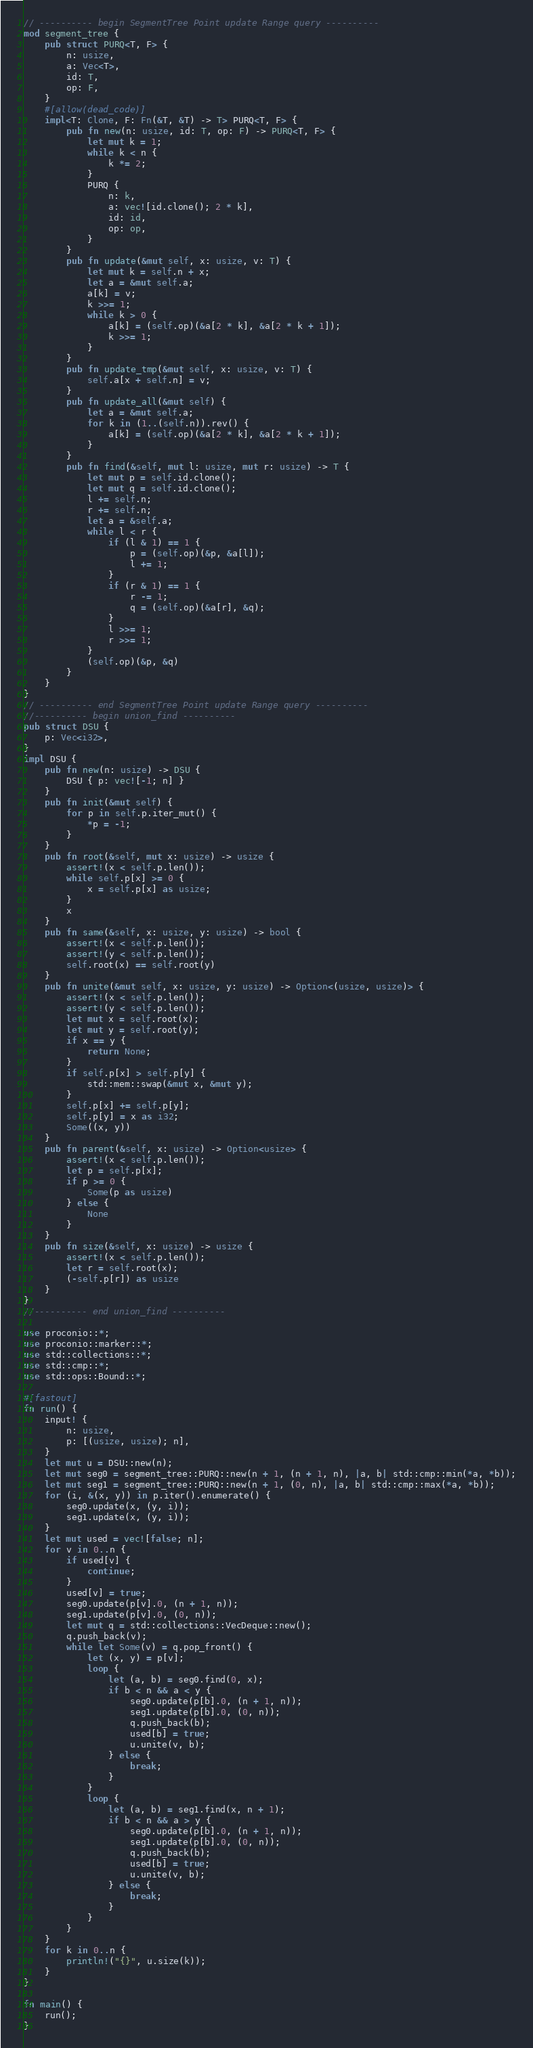Convert code to text. <code><loc_0><loc_0><loc_500><loc_500><_Rust_>// ---------- begin SegmentTree Point update Range query ----------
mod segment_tree {
    pub struct PURQ<T, F> {
        n: usize,
        a: Vec<T>,
        id: T,
        op: F,
    }
    #[allow(dead_code)]
    impl<T: Clone, F: Fn(&T, &T) -> T> PURQ<T, F> {
        pub fn new(n: usize, id: T, op: F) -> PURQ<T, F> {
            let mut k = 1;
            while k < n {
                k *= 2;
            }
            PURQ {
                n: k,
                a: vec![id.clone(); 2 * k],
                id: id,
                op: op,
            }
        }
        pub fn update(&mut self, x: usize, v: T) {
            let mut k = self.n + x;
            let a = &mut self.a;
            a[k] = v;
            k >>= 1;
            while k > 0 {
                a[k] = (self.op)(&a[2 * k], &a[2 * k + 1]);
                k >>= 1;
            }
        }
        pub fn update_tmp(&mut self, x: usize, v: T) {
            self.a[x + self.n] = v;
        }
        pub fn update_all(&mut self) {
            let a = &mut self.a;
            for k in (1..(self.n)).rev() {
                a[k] = (self.op)(&a[2 * k], &a[2 * k + 1]);
            }
        }
        pub fn find(&self, mut l: usize, mut r: usize) -> T {
            let mut p = self.id.clone();
            let mut q = self.id.clone();
            l += self.n;
            r += self.n;
            let a = &self.a;
            while l < r {
                if (l & 1) == 1 {
                    p = (self.op)(&p, &a[l]);
                    l += 1;
                }
                if (r & 1) == 1 {
                    r -= 1;
                    q = (self.op)(&a[r], &q);
                }
                l >>= 1;
                r >>= 1;
            }
            (self.op)(&p, &q)
        }
    }
}
// ---------- end SegmentTree Point update Range query ----------
//---------- begin union_find ----------
pub struct DSU {
    p: Vec<i32>,
}
impl DSU {
    pub fn new(n: usize) -> DSU {
        DSU { p: vec![-1; n] }
    }
    pub fn init(&mut self) {
        for p in self.p.iter_mut() {
            *p = -1;
        }
    }
    pub fn root(&self, mut x: usize) -> usize {
        assert!(x < self.p.len());
        while self.p[x] >= 0 {
            x = self.p[x] as usize;
        }
        x
    }
    pub fn same(&self, x: usize, y: usize) -> bool {
        assert!(x < self.p.len());
        assert!(y < self.p.len());
        self.root(x) == self.root(y)
    }
    pub fn unite(&mut self, x: usize, y: usize) -> Option<(usize, usize)> {
        assert!(x < self.p.len());
        assert!(y < self.p.len());
        let mut x = self.root(x);
        let mut y = self.root(y);
        if x == y {
            return None;
        }
        if self.p[x] > self.p[y] {
            std::mem::swap(&mut x, &mut y);
        }
        self.p[x] += self.p[y];
        self.p[y] = x as i32;
        Some((x, y))
    }
    pub fn parent(&self, x: usize) -> Option<usize> {
        assert!(x < self.p.len());
        let p = self.p[x];
        if p >= 0 {
            Some(p as usize)
        } else {
            None
        }
    }
    pub fn size(&self, x: usize) -> usize {
        assert!(x < self.p.len());
        let r = self.root(x);
        (-self.p[r]) as usize
    }
}
//---------- end union_find ----------

use proconio::*;
use proconio::marker::*;
use std::collections::*;
use std::cmp::*;
use std::ops::Bound::*;

#[fastout]
fn run() {
    input! {
        n: usize,
        p: [(usize, usize); n],
    }
    let mut u = DSU::new(n);
    let mut seg0 = segment_tree::PURQ::new(n + 1, (n + 1, n), |a, b| std::cmp::min(*a, *b));
    let mut seg1 = segment_tree::PURQ::new(n + 1, (0, n), |a, b| std::cmp::max(*a, *b));
    for (i, &(x, y)) in p.iter().enumerate() {
        seg0.update(x, (y, i));
        seg1.update(x, (y, i));
    }
    let mut used = vec![false; n];
    for v in 0..n {
        if used[v] {
            continue;
        }
        used[v] = true;
        seg0.update(p[v].0, (n + 1, n));
        seg1.update(p[v].0, (0, n));
        let mut q = std::collections::VecDeque::new();
        q.push_back(v);
        while let Some(v) = q.pop_front() {
            let (x, y) = p[v];
            loop {
                let (a, b) = seg0.find(0, x);
                if b < n && a < y {
                    seg0.update(p[b].0, (n + 1, n));
                    seg1.update(p[b].0, (0, n));
                    q.push_back(b);
                    used[b] = true;
                    u.unite(v, b);
                } else {
                    break;
                }
            }
            loop {
                let (a, b) = seg1.find(x, n + 1);
                if b < n && a > y {
                    seg0.update(p[b].0, (n + 1, n));
                    seg1.update(p[b].0, (0, n));
                    q.push_back(b);
                    used[b] = true;
                    u.unite(v, b);
                } else {
                    break;
                }
            }
        }
    }
    for k in 0..n {
        println!("{}", u.size(k));
    }
}

fn main() {
    run();
}
</code> 